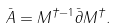Convert formula to latex. <formula><loc_0><loc_0><loc_500><loc_500>\bar { A } = M ^ { \dagger - 1 } \bar { \partial } M ^ { \dagger } .</formula> 